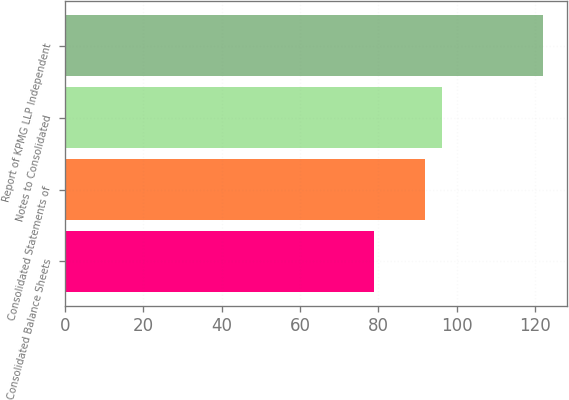Convert chart. <chart><loc_0><loc_0><loc_500><loc_500><bar_chart><fcel>Consolidated Balance Sheets<fcel>Consolidated Statements of<fcel>Notes to Consolidated<fcel>Report of KPMG LLP Independent<nl><fcel>79<fcel>91.9<fcel>96.2<fcel>122<nl></chart> 